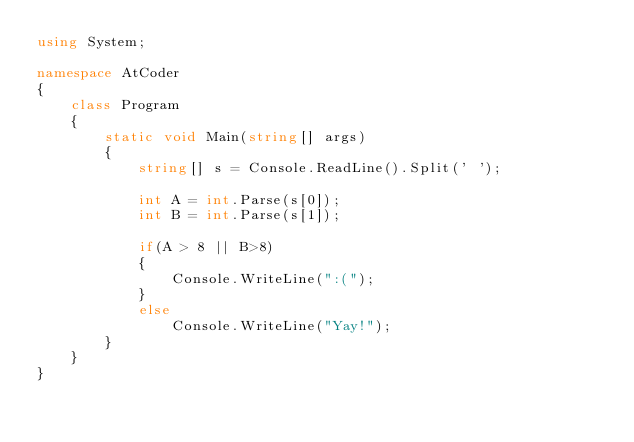Convert code to text. <code><loc_0><loc_0><loc_500><loc_500><_C#_>using System;

namespace AtCoder
{
    class Program
    {
        static void Main(string[] args)
        {
            string[] s = Console.ReadLine().Split(' ');

            int A = int.Parse(s[0]);
            int B = int.Parse(s[1]);

            if(A > 8 || B>8)
            {
                Console.WriteLine(":(");
            }
            else
                Console.WriteLine("Yay!");
        }
    }
}
</code> 